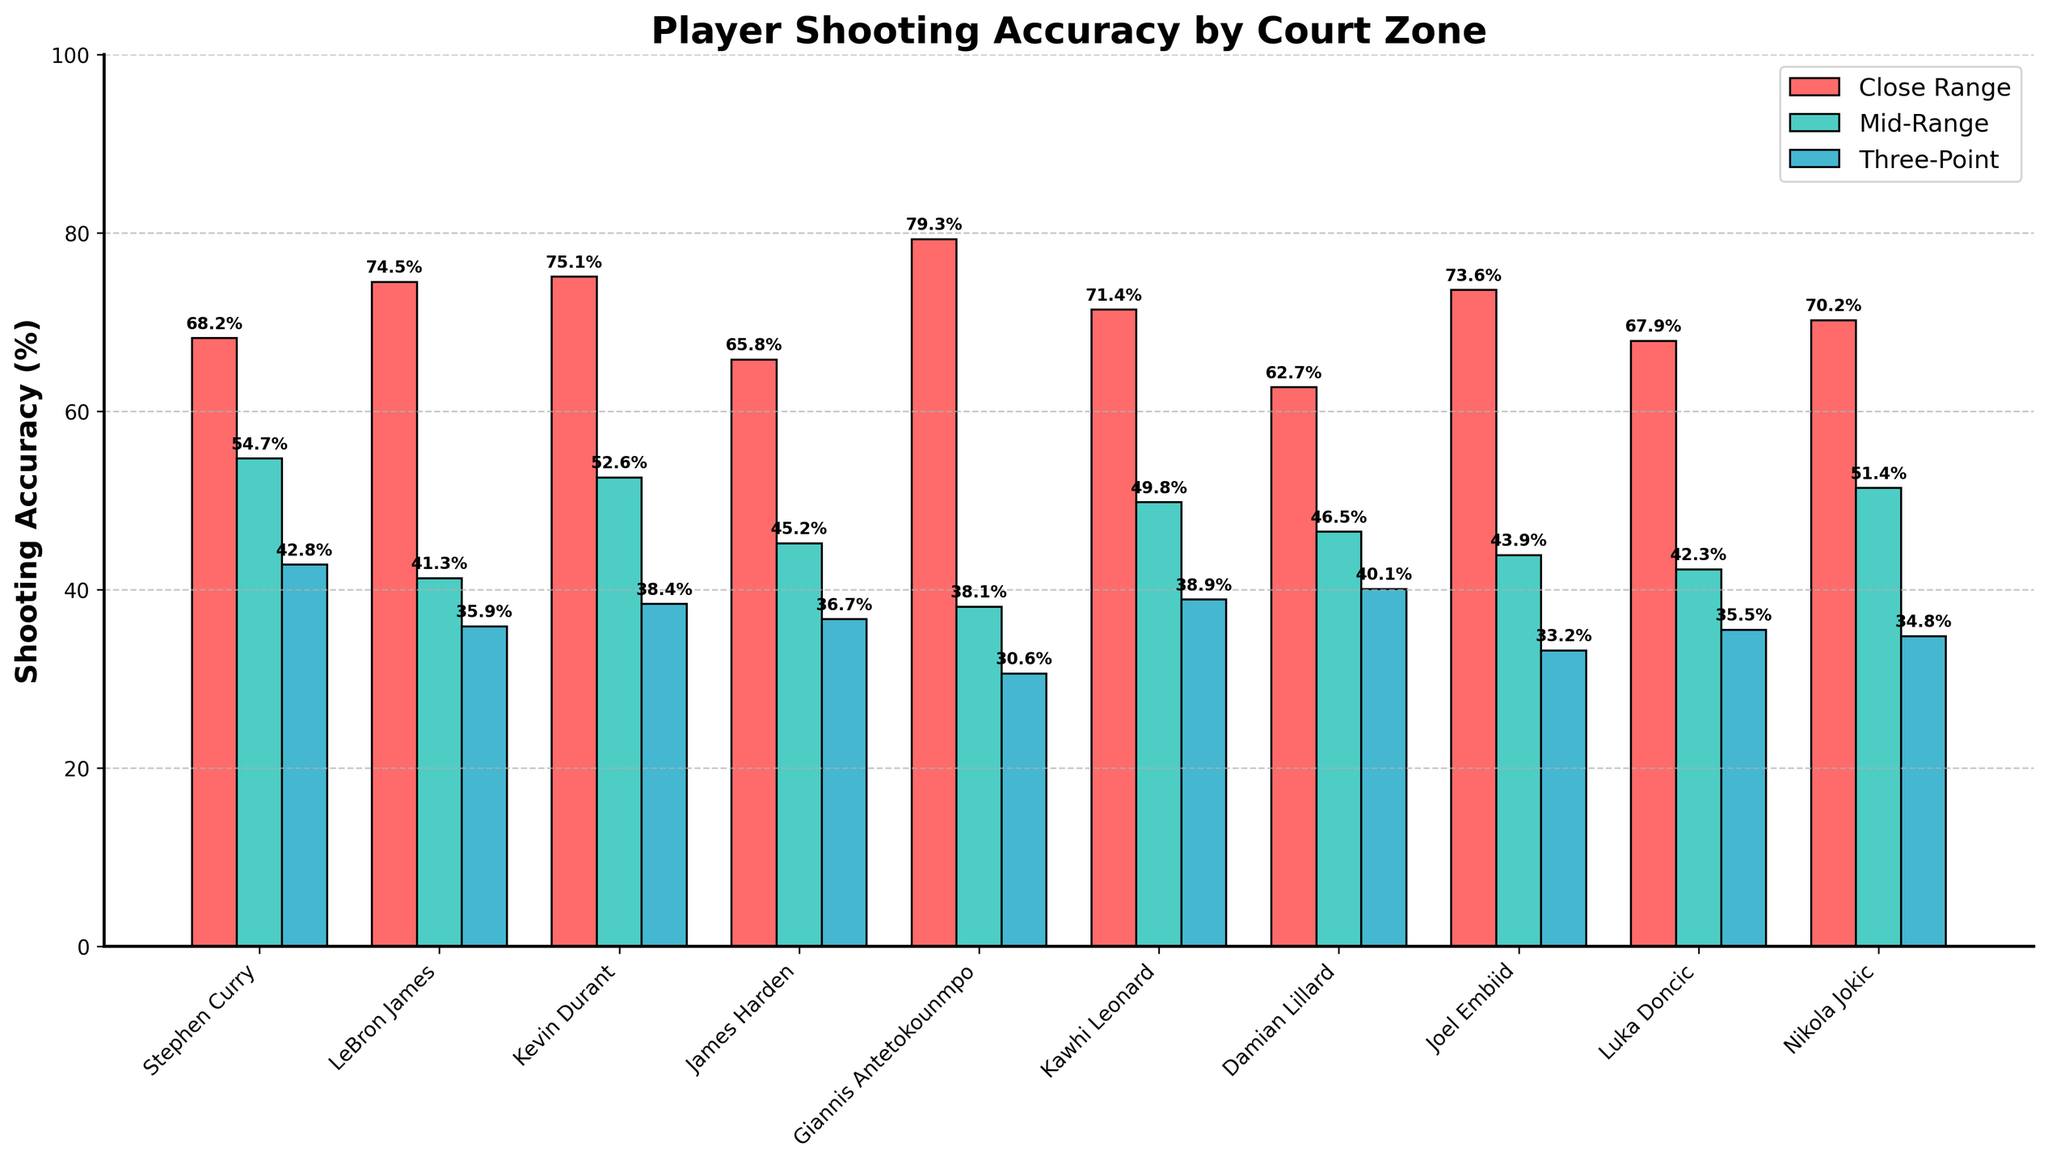Which player has the highest shooting accuracy in the close range? Giannis Antetokounmpo has the highest close-range shooting accuracy at 79.3% as shown by the tallest red bar in the close-range category.
Answer: Giannis Antetokounmpo How does Stephen Curry's three-point shooting accuracy compare to Kevin Durant's? Stephen Curry has a three-point shooting accuracy of 42.8%, while Kevin Durant has 38.4%. Stephen Curry's blue bar is taller than Kevin Durant's in the three-point section.
Answer: Stephen Curry has higher accuracy Which players have mid-range shooting accuracy above 50%? Stephen Curry (54.7%), Kevin Durant (52.6%), and Nikola Jokic (51.4%) have shooting accuracies above 50% for mid-range, indicated by green bars taller than the 50% mark.
Answer: Stephen Curry, Kevin Durant, Nikola Jokic What is the average shooting accuracy for LeBron James across all court zones? Average = (74.5% + 41.3% + 35.9%)/3 = 50.5666%. First, sum the shooting accuracies (74.5 + 41.3 + 35.9 = 151.7) and then divide by 3.
Answer: 50.6% Which player has the greatest difference between their close range and three-point shooting accuracy? Giannis Antetokounmpo has the greatest difference (48.7%). First, compute the difference for each player (close range percentage - three-point percentage). Giannis' is 79.3 - 30.6 = 48.7.
Answer: Giannis Antetokounmpo Compare the heights of the bars for mid-range accuracy. Who has both the highest and lowest mid-range accuracy? Stephen Curry has the highest mid-range accuracy (54.7%), while Giannis Antetokounmpo has the lowest (38.1%) as shown by the tallest and shortest green bars respectively.
Answer: Stephen Curry (highest), Giannis Antetokounmpo (lowest) Which players have a higher shooting accuracy in mid-range than in three-point range? Stephen Curry, Kevin Durant, James Harden, Kawhi Leonard, Damian Lillard, Joel Embiid, Luka Doncic, and Nikola Jokic have higher mid-range accuracy than three-point. The mid-range (green) bars are taller than the three-point (blue) bars for these players.
Answer: Stephen Curry, Kevin Durant, James Harden, Kawhi Leonard, Damian Lillard, Joel Embiid, Luka Doncic, Nikola Jokic What is the sum of close-range shooting percentages for Kawhi Leonard and Damian Lillard? Sum = 71.4% + 62.7% = 134.1%. Add Kawhi Leonard's (71.4%) and Damian Lillard's (62.7%) close-range percentages.
Answer: 134.1% What is the average three-point shooting accuracy for James Harden and Damian Lillard? Average = (36.7% + 40.1%)/2 = 38.4%. Sum their three-point accuracies (36.7 + 40.1 = 76.8) and divide by 2.
Answer: 38.4% Who has the highest difference in shooting accuracy between mid-range and three-point shots? Stephen Curry has the largest difference (11.9%). Calculate the differences (mid-range - three-point): Stephen's is 54.7 - 42.8 = 11.9.
Answer: Stephen Curry 